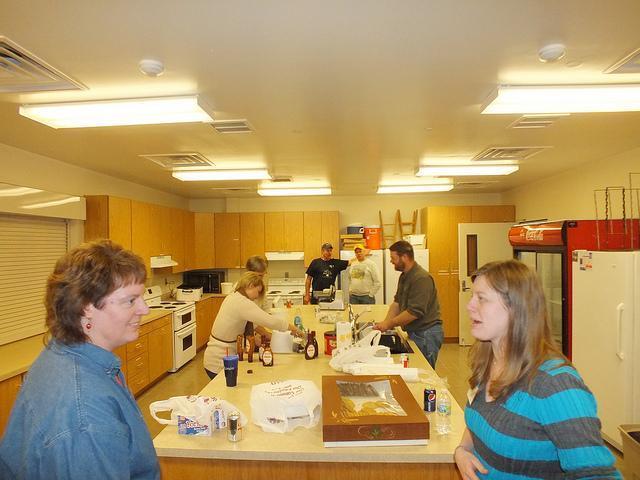How many people are eating?
Give a very brief answer. 0. How many refrigerators are there?
Give a very brief answer. 2. How many people are there?
Give a very brief answer. 4. How many hot dogs are there?
Give a very brief answer. 0. 